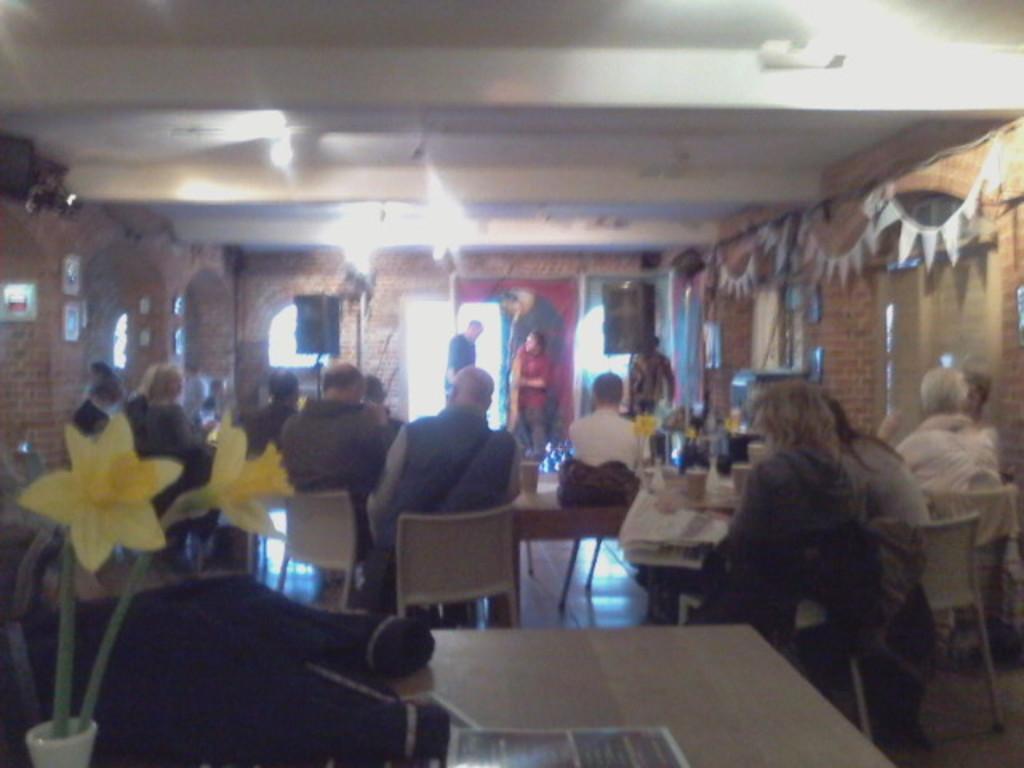Could you give a brief overview of what you see in this image? In this image, we can see some persons wearing clothes and sitting on chairs. There is a table at the bottom of the image. There is a flower vase in the bottom left of the image. There are two persons in the middle of the image standing and wearing clothes. 